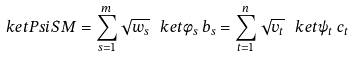Convert formula to latex. <formula><loc_0><loc_0><loc_500><loc_500>\ k e t P s i S M = \sum _ { s = 1 } ^ { m } \sqrt { w _ { s } } \, \ k e t { \phi _ { s } \, b _ { s } } = \sum _ { t = 1 } ^ { n } \sqrt { v _ { t } } \, \ k e t { \psi _ { t } \, c _ { t } }</formula> 